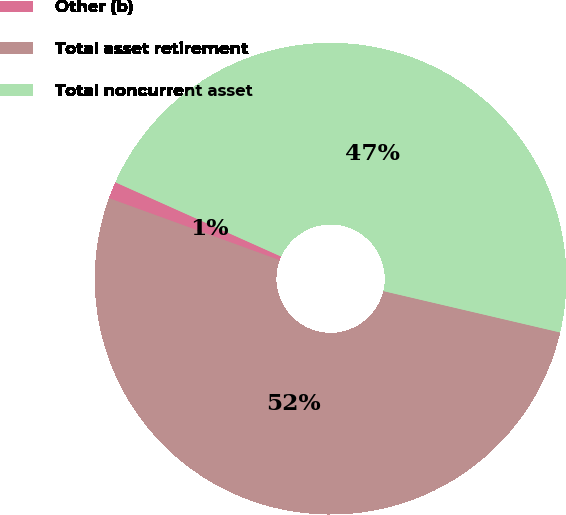Convert chart. <chart><loc_0><loc_0><loc_500><loc_500><pie_chart><fcel>Other (b)<fcel>Total asset retirement<fcel>Total noncurrent asset<nl><fcel>1.16%<fcel>51.88%<fcel>46.95%<nl></chart> 